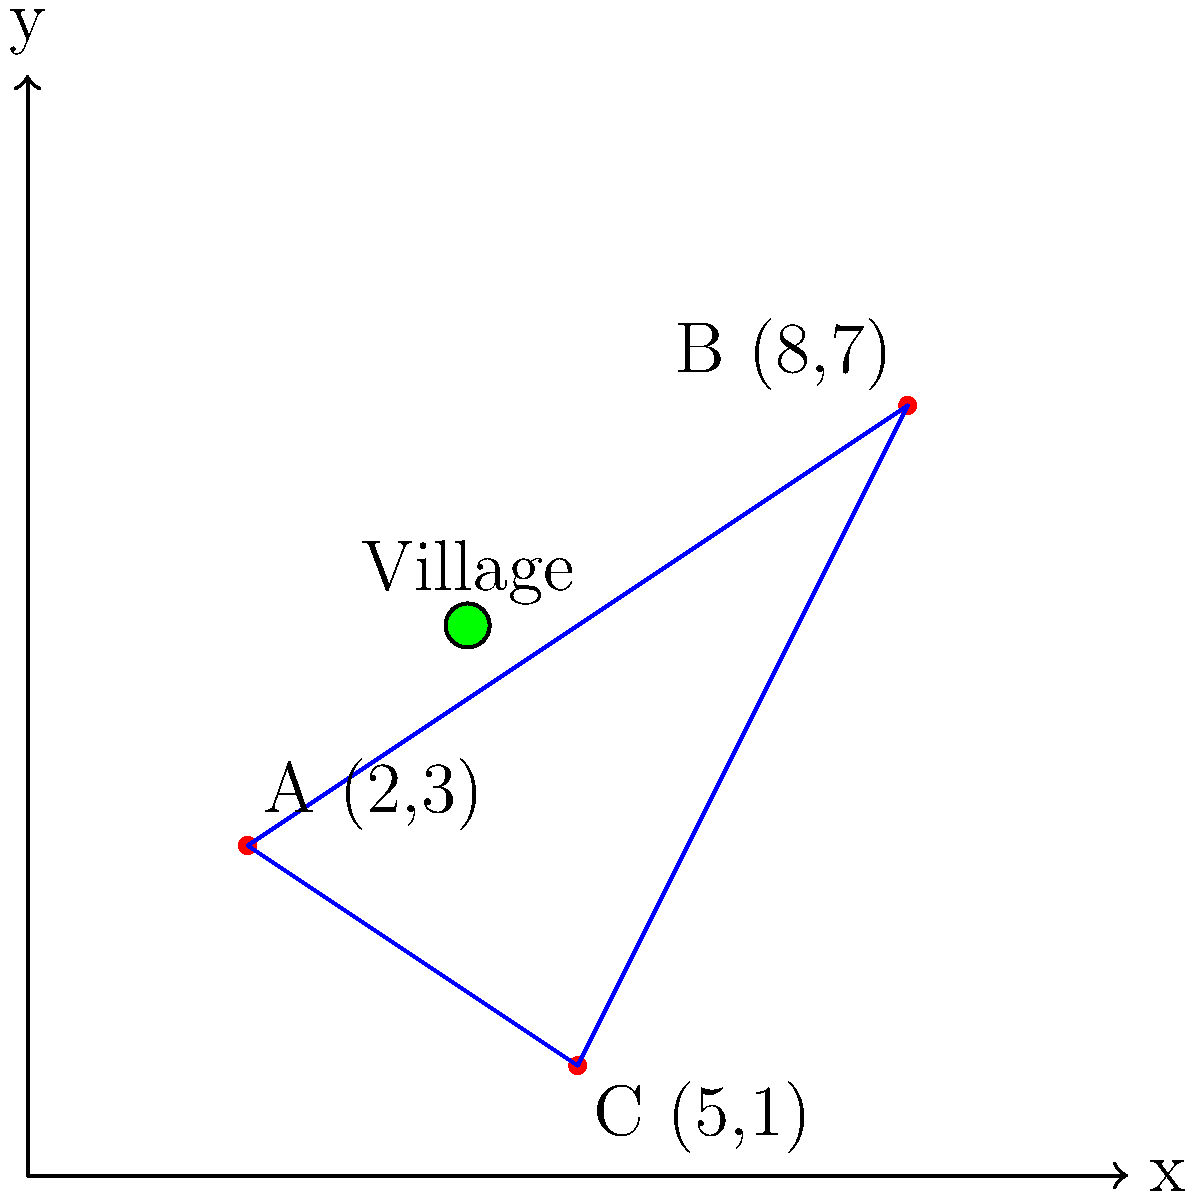A mining company needs to transport minerals from three extraction points A(2,3), B(8,7), and C(5,1) to a processing facility. The most efficient route would connect all three points, forming a triangle. However, there's a village located at (4,5) that needs to be considered to minimize the impact on local roads. Which of the three sides of the triangle formed by A, B, and C passes closest to the village, and what is its distance from the village? Round your answer to two decimal places. To solve this problem, we need to follow these steps:

1) First, we need to find the equations of the three lines forming the triangle:
   
   Line AB: $y = \frac{4}{6}x + \frac{5}{3}$
   Line BC: $y = -1x + 15$
   Line CA: $y = -\frac{2}{3}x + \frac{13}{3}$

2) Next, we need to calculate the distance from the village (4,5) to each of these lines using the point-to-line distance formula:

   $d = \frac{|ax_0 + by_0 + c|}{\sqrt{a^2 + b^2}}$

   Where $(x_0,y_0)$ is the point (4,5) and $ax + by + c = 0$ is the general form of each line equation.

3) For line AB:
   $\frac{4}{6}x - y + \frac{5}{3} = 0$
   $d_{AB} = \frac{|\frac{4}{6}(4) - 5 + \frac{5}{3}|}{\sqrt{(\frac{4}{6})^2 + (-1)^2}} = 1.44$

4) For line BC:
   $-x + y - 15 = 0$
   $d_{BC} = \frac{|-4 + 5 - 15|}{\sqrt{(-1)^2 + 1^2}} = 9.90$

5) For line CA:
   $-\frac{2}{3}x - y + \frac{13}{3} = 0$
   $d_{CA} = \frac{|-\frac{2}{3}(4) - 5 + \frac{13}{3}|}{\sqrt{(-\frac{2}{3})^2 + (-1)^2}} = 0.77$

6) The shortest distance is 0.77, which corresponds to line CA.
Answer: Line CA, 0.77 units 